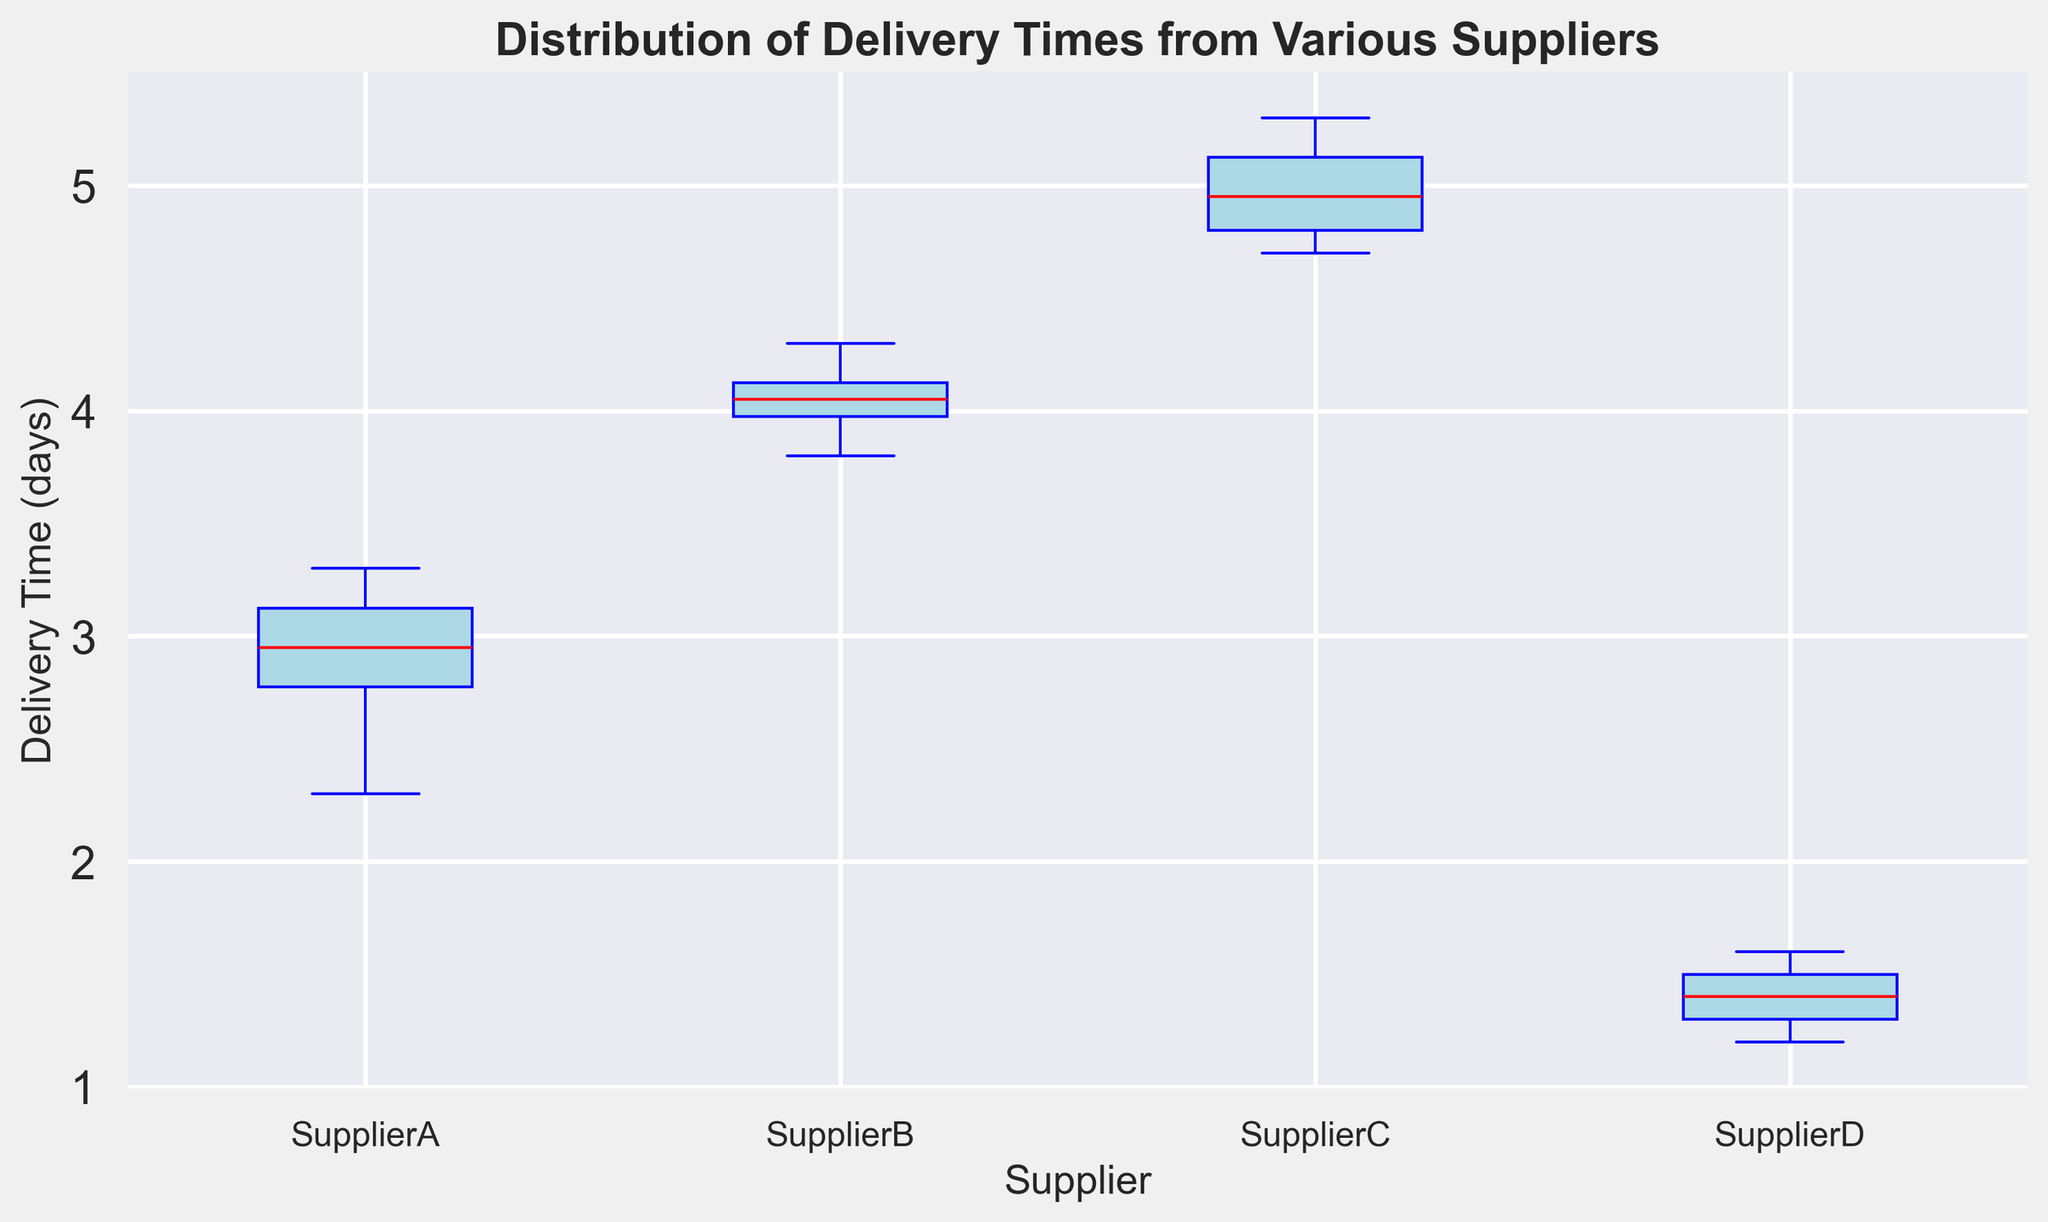What's the median delivery time for Supplier B? To find the median delivery time, look at the center line in the box for Supplier B. The median is represented by the red line inside the box.
Answer: 4.1 days Which supplier has the shortest median delivery time? Compare the median lines (red lines) for each supplier's box. The shortest median line corresponds to the smallest delivery time.
Answer: Supplier D Is the delivery time range for Supplier A larger or smaller than Supplier C? To compare the ranges, look at the length of the boxes and the whiskers for Supplier A and Supplier C. The range is the distance between the top whisker and the bottom whisker.
Answer: Smaller What is the interquartile range (IQR) for Supplier A? The IQR is the range between the first quartile (bottom of the box) and the third quartile (top of the box) in the box plot for Supplier A. Measure the difference between these two values.
Answer: 0.5 days (3.1 - 2.6) Which supplier has the most consistent delivery times? Consistency can be determined by the smallest interquartile range (IQR). Look for the box that has the smallest height.
Answer: Supplier D Which supplier shows the most variability in delivery times? Variability is indicated by the largest interquartile range (IQR) and the longest whiskers. Identify the box plot that is the tallest and has the longest lines extending from it.
Answer: Supplier C How do Supplier B's maximum delivery times compare to Supplier A's maximum delivery times? Check the top whiskers of the box plots for Supplier B and Supplier A. The position of the top whiskers will show which one has the higher maximum delivery time.
Answer: Supplier B's maximum is higher Are there any outliers in the delivery times for any suppliers? Outliers are represented as individual points outside the whiskers. Look for any isolated dots above or below the whiskers of each box plot.
Answer: No Between which suppliers is the difference in median delivery time the greatest? Compare the red median lines across the boxes and find the two boxes with the largest vertical distance between their median lines.
Answer: Supplier C and Supplier D 